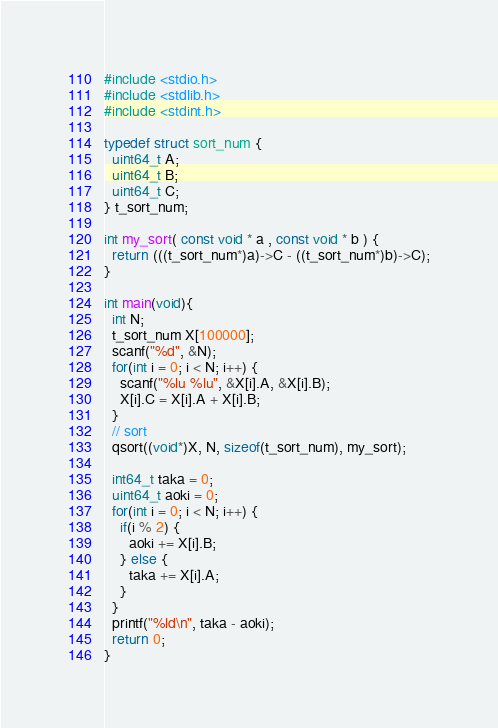Convert code to text. <code><loc_0><loc_0><loc_500><loc_500><_C_>#include <stdio.h>
#include <stdlib.h>
#include <stdint.h>

typedef struct sort_num {
  uint64_t A;
  uint64_t B;
  uint64_t C;
} t_sort_num;

int my_sort( const void * a , const void * b ) {
  return (((t_sort_num*)a)->C - ((t_sort_num*)b)->C);
}

int main(void){
  int N;
  t_sort_num X[100000];
  scanf("%d", &N);
  for(int i = 0; i < N; i++) {
    scanf("%lu %lu", &X[i].A, &X[i].B);
    X[i].C = X[i].A + X[i].B;
  }
  // sort
  qsort((void*)X, N, sizeof(t_sort_num), my_sort);

  int64_t taka = 0;
  uint64_t aoki = 0;
  for(int i = 0; i < N; i++) {
    if(i % 2) {
      aoki += X[i].B;
    } else {
      taka += X[i].A;
    }
  }
  printf("%ld\n", taka - aoki);
  return 0;
}
</code> 